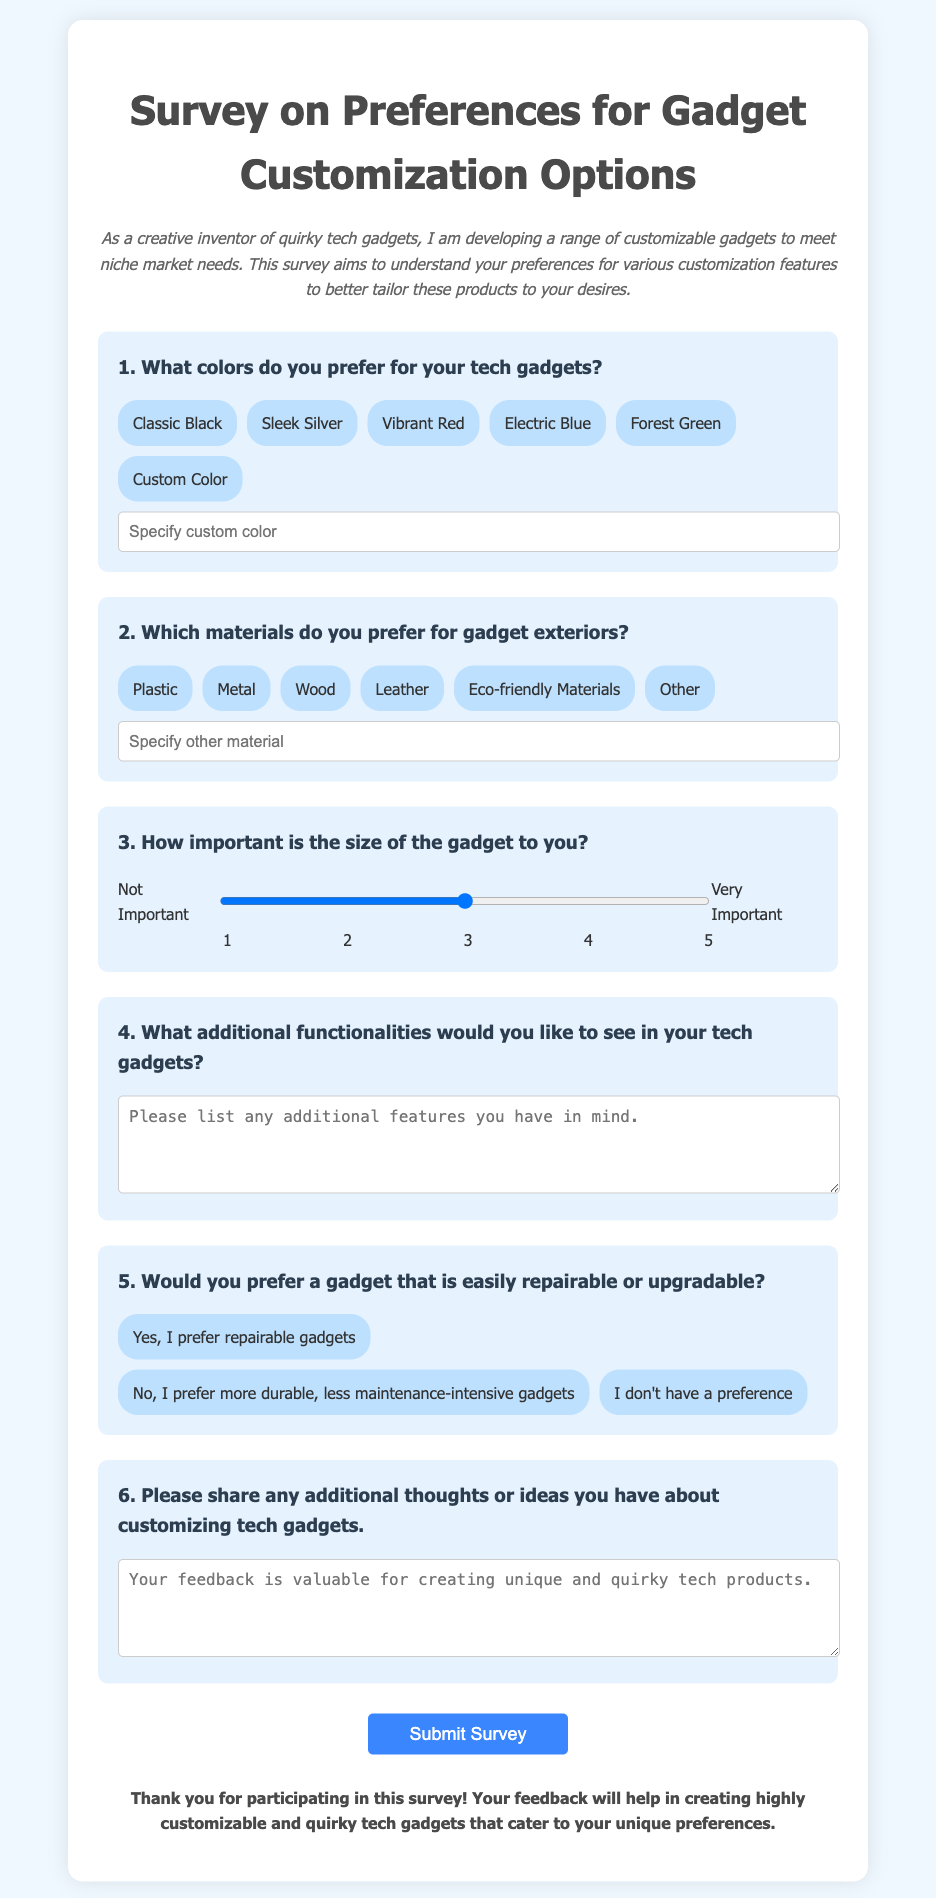What is the title of the survey? The title of the survey is displayed prominently at the top of the document.
Answer: Survey on Preferences for Gadget Customization Options How many color options are provided for the tech gadgets? The survey lists a total of six different color options for the gadgets.
Answer: 6 What types of materials can you choose for the gadget exteriors? The document includes six material choices for users to select from in the survey.
Answer: 6 On a scale of 1 to 5, how is the importance of gadget size rated? The document features a scale where users can rate the importance of the gadget size from 1 (Not Important) to 5 (Very Important).
Answer: 1 to 5 What types of functionality are users asked to describe? The survey asks users to list any additional features they'd like to see in their gadgets.
Answer: Additional functionalities Does the survey allow for custom colors? The document mentions the option for users to specify a custom color if they choose that option.
Answer: Yes What preference regarding repairability or upgradability is questioned? The survey asks users if they prefer gadgets that are easily repairable or upgradable.
Answer: Repairable or upgradable How many thoughts or ideas is the user asked to share at the end? The survey requests users to provide any additional thoughts or ideas about customizing tech gadgets in a text area.
Answer: Any number of thoughts or ideas 